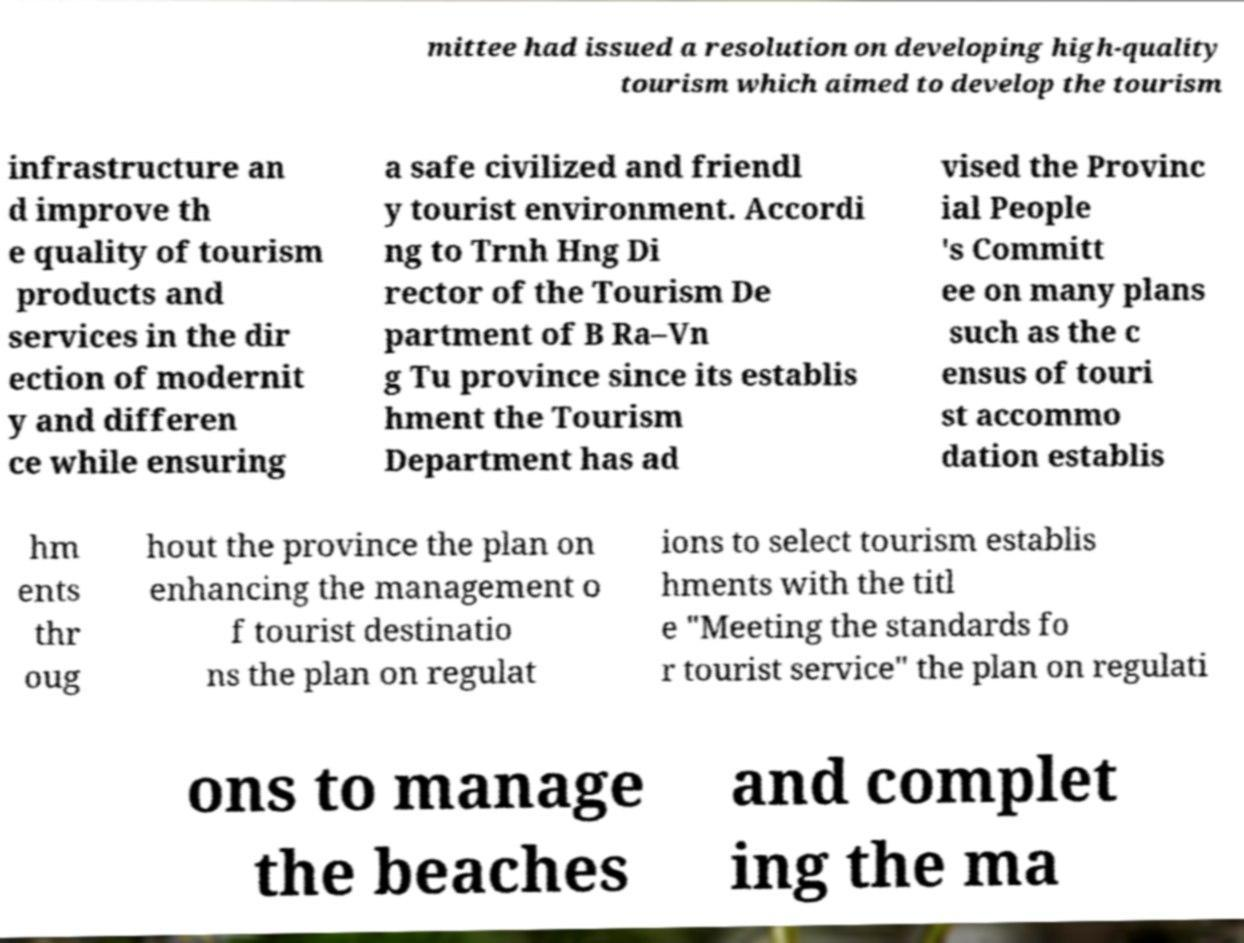Please identify and transcribe the text found in this image. mittee had issued a resolution on developing high-quality tourism which aimed to develop the tourism infrastructure an d improve th e quality of tourism products and services in the dir ection of modernit y and differen ce while ensuring a safe civilized and friendl y tourist environment. Accordi ng to Trnh Hng Di rector of the Tourism De partment of B Ra–Vn g Tu province since its establis hment the Tourism Department has ad vised the Provinc ial People 's Committ ee on many plans such as the c ensus of touri st accommo dation establis hm ents thr oug hout the province the plan on enhancing the management o f tourist destinatio ns the plan on regulat ions to select tourism establis hments with the titl e "Meeting the standards fo r tourist service" the plan on regulati ons to manage the beaches and complet ing the ma 